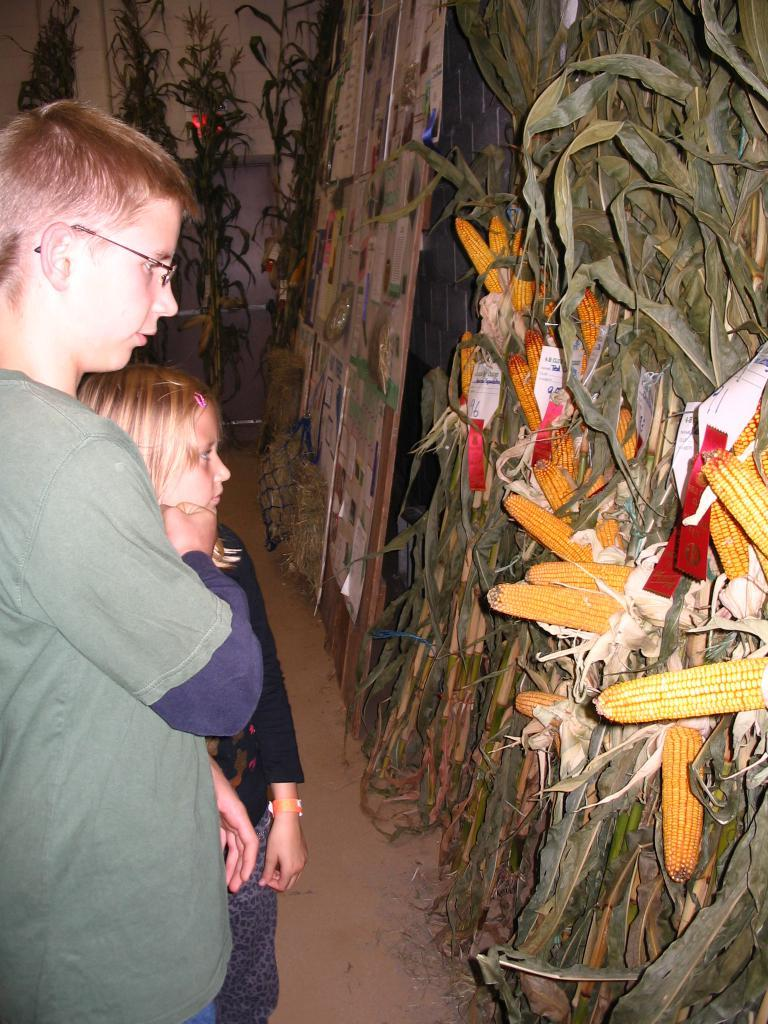What type of crop is visible in the image? There is maize in the image. What other items in the image have text on them? There are tags and posters with text in the image. What type of vegetation is present in the image? There are plants in the image. What are the humans in the image doing? The humans are standing and watching in the image. What type of drug is being administered to the plants in the image? There is no indication of any drug being administered to the plants in the image. 